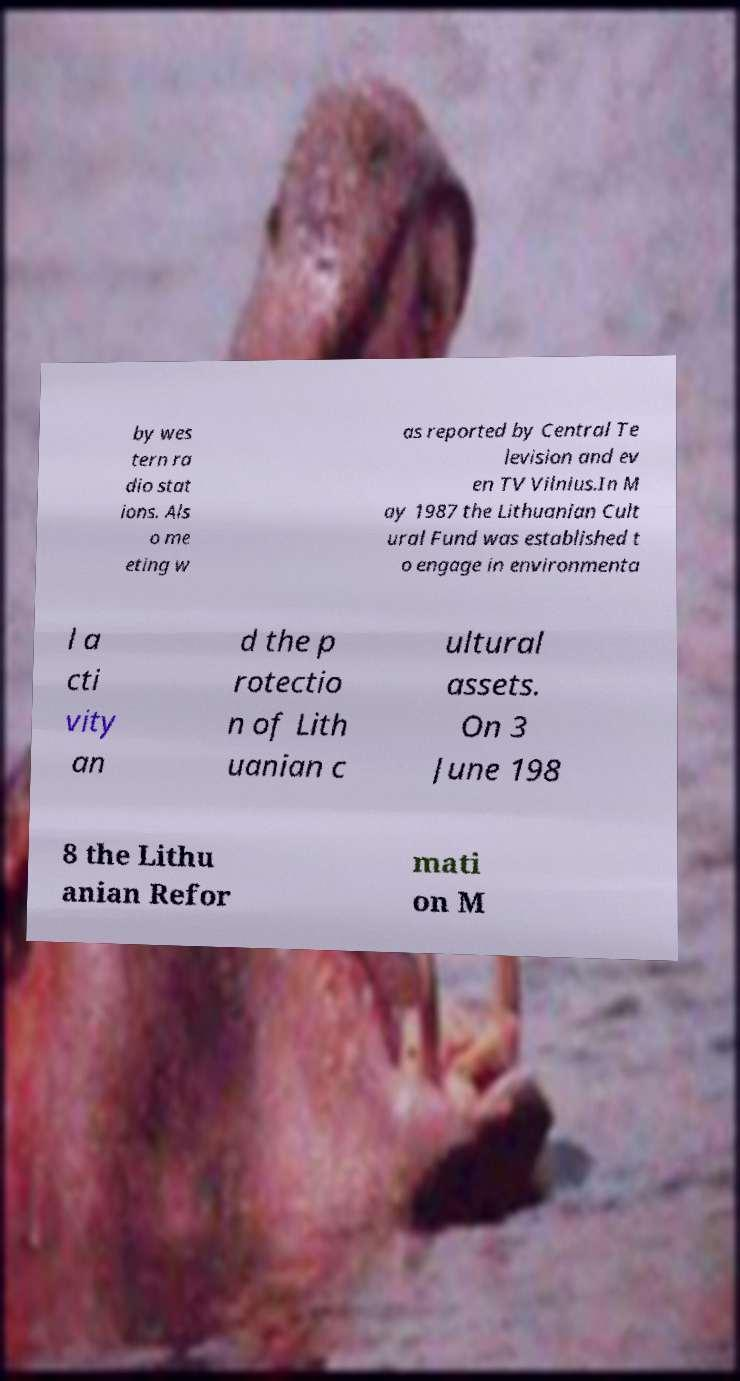For documentation purposes, I need the text within this image transcribed. Could you provide that? by wes tern ra dio stat ions. Als o me eting w as reported by Central Te levision and ev en TV Vilnius.In M ay 1987 the Lithuanian Cult ural Fund was established t o engage in environmenta l a cti vity an d the p rotectio n of Lith uanian c ultural assets. On 3 June 198 8 the Lithu anian Refor mati on M 